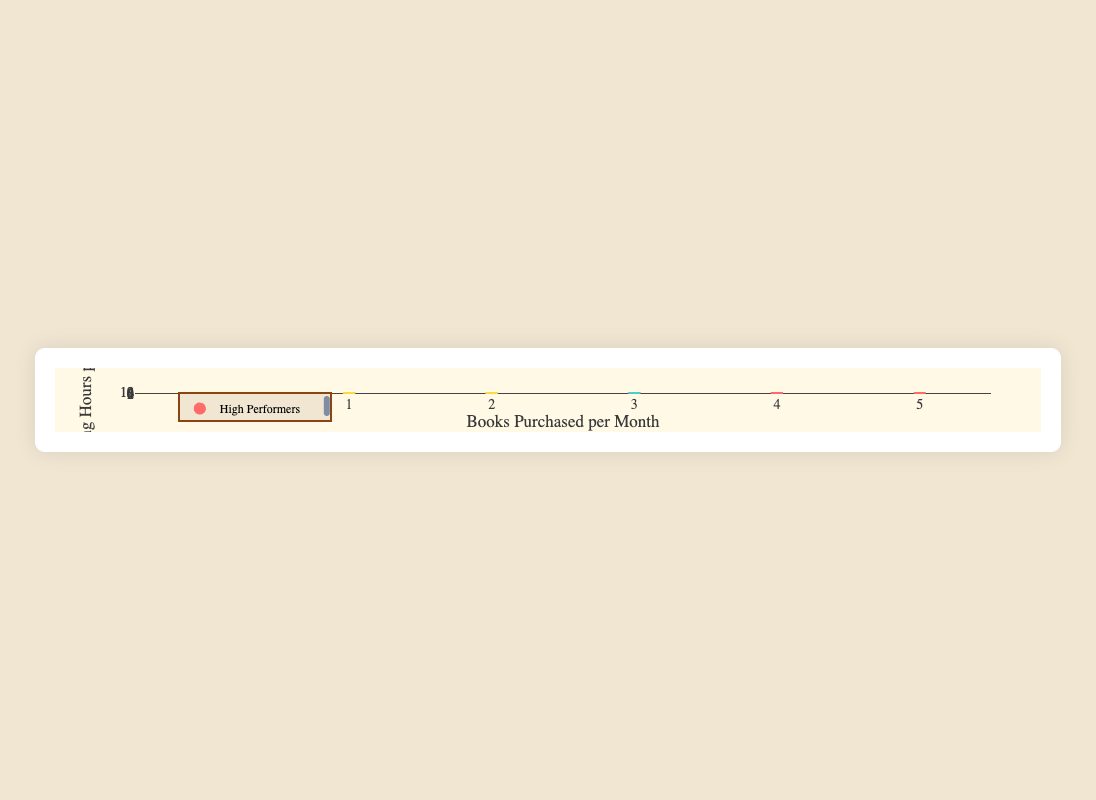How many students in total are represented in the figure? Count all the total unique student data points visible in the scatter plot.
Answer: 9 Which academic performance group has the highest average reading hours per week? Calculate the average reading hours for each group. High: (10+12+9)/3 = 10.33, Medium: (7+5+6)/3 = 6, Low: (3+1+4)/3 = 2.67. High performers have the highest average.
Answer: High What is the range of books purchased per month for Medium performers? Identify the minimum and maximum number of books purchased per month for the Medium group. Minimum is 1 (Olivia Brown) and maximum is 3 (Liam Davis), so the range is 3 - 1 = 2.
Answer: 2 Who reads the most hours per week, and what is their academic performance level? Identify the data point with the highest y-axis value (reading hours per week). Michael Smith reads 12 hours per week and has a high academic performance.
Answer: Michael Smith, High Is there any student who did not purchase any books? If yes, what is their academic performance level? Look for data points where books purchased per month are 0. Benjamin Moore did not purchase any books and belongs to the Low academic performance group.
Answer: Yes, Low What is the difference in the number of books purchased per month between the highest and lowest readers? Identify the highest reader (Michael Smith, 12 hours) and the lowest reader (Benjamin Moore, 1 hour). Difference in books purchased: 5 - 0 = 5.
Answer: 5 Which student from the Medium group has the fewest reading hours per week? Find the minimum reading hours per week within Medium performers. Olivia Brown reads 5 hours per week.
Answer: Olivia Brown Compare the trend between books purchased and reading hours in High vs. Low performers. Which group shows a clearer positive correlation? Identify if higher reading hours correlate with more books purchased within each group visually. High performers show a clearer positive correlation.
Answer: High What is the median number of books purchased for all students combined? List all books purchased values: [4, 5, 3, 2, 1, 3, 1, 0, 2]. Median is the middle value in the ordered list [0, 1, 1, 2, 2, 3, 3, 4, 5], which is 2.
Answer: 2 